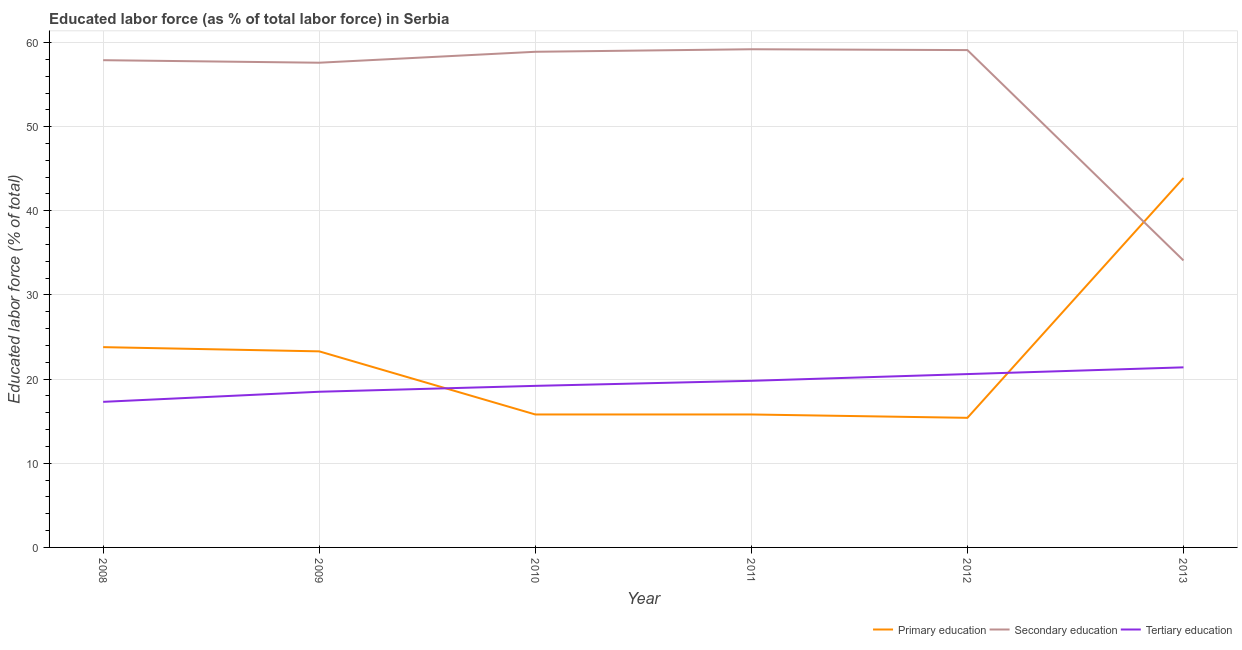How many different coloured lines are there?
Provide a succinct answer. 3. What is the percentage of labor force who received primary education in 2009?
Your response must be concise. 23.3. Across all years, what is the maximum percentage of labor force who received secondary education?
Provide a short and direct response. 59.2. Across all years, what is the minimum percentage of labor force who received primary education?
Provide a succinct answer. 15.4. In which year was the percentage of labor force who received secondary education maximum?
Ensure brevity in your answer.  2011. What is the total percentage of labor force who received tertiary education in the graph?
Offer a terse response. 116.8. What is the difference between the percentage of labor force who received secondary education in 2008 and that in 2013?
Ensure brevity in your answer.  23.8. What is the difference between the percentage of labor force who received primary education in 2010 and the percentage of labor force who received tertiary education in 2009?
Ensure brevity in your answer.  -2.7. What is the average percentage of labor force who received secondary education per year?
Your answer should be compact. 54.47. In the year 2010, what is the difference between the percentage of labor force who received primary education and percentage of labor force who received tertiary education?
Give a very brief answer. -3.4. What is the ratio of the percentage of labor force who received primary education in 2008 to that in 2010?
Give a very brief answer. 1.51. Is the difference between the percentage of labor force who received primary education in 2008 and 2010 greater than the difference between the percentage of labor force who received tertiary education in 2008 and 2010?
Give a very brief answer. Yes. What is the difference between the highest and the second highest percentage of labor force who received secondary education?
Offer a terse response. 0.1. What is the difference between the highest and the lowest percentage of labor force who received primary education?
Provide a succinct answer. 28.5. Does the percentage of labor force who received primary education monotonically increase over the years?
Your answer should be very brief. No. Is the percentage of labor force who received primary education strictly greater than the percentage of labor force who received tertiary education over the years?
Ensure brevity in your answer.  No. How many lines are there?
Your answer should be very brief. 3. Does the graph contain any zero values?
Ensure brevity in your answer.  No. How are the legend labels stacked?
Your answer should be compact. Horizontal. What is the title of the graph?
Keep it short and to the point. Educated labor force (as % of total labor force) in Serbia. Does "Labor Market" appear as one of the legend labels in the graph?
Ensure brevity in your answer.  No. What is the label or title of the Y-axis?
Provide a succinct answer. Educated labor force (% of total). What is the Educated labor force (% of total) in Primary education in 2008?
Provide a short and direct response. 23.8. What is the Educated labor force (% of total) in Secondary education in 2008?
Your response must be concise. 57.9. What is the Educated labor force (% of total) of Tertiary education in 2008?
Your answer should be compact. 17.3. What is the Educated labor force (% of total) of Primary education in 2009?
Provide a short and direct response. 23.3. What is the Educated labor force (% of total) in Secondary education in 2009?
Provide a succinct answer. 57.6. What is the Educated labor force (% of total) in Tertiary education in 2009?
Your answer should be compact. 18.5. What is the Educated labor force (% of total) of Primary education in 2010?
Ensure brevity in your answer.  15.8. What is the Educated labor force (% of total) in Secondary education in 2010?
Your answer should be compact. 58.9. What is the Educated labor force (% of total) of Tertiary education in 2010?
Make the answer very short. 19.2. What is the Educated labor force (% of total) of Primary education in 2011?
Ensure brevity in your answer.  15.8. What is the Educated labor force (% of total) in Secondary education in 2011?
Give a very brief answer. 59.2. What is the Educated labor force (% of total) of Tertiary education in 2011?
Offer a very short reply. 19.8. What is the Educated labor force (% of total) of Primary education in 2012?
Ensure brevity in your answer.  15.4. What is the Educated labor force (% of total) of Secondary education in 2012?
Make the answer very short. 59.1. What is the Educated labor force (% of total) of Tertiary education in 2012?
Your answer should be compact. 20.6. What is the Educated labor force (% of total) in Primary education in 2013?
Offer a terse response. 43.9. What is the Educated labor force (% of total) in Secondary education in 2013?
Keep it short and to the point. 34.1. What is the Educated labor force (% of total) of Tertiary education in 2013?
Ensure brevity in your answer.  21.4. Across all years, what is the maximum Educated labor force (% of total) of Primary education?
Make the answer very short. 43.9. Across all years, what is the maximum Educated labor force (% of total) in Secondary education?
Provide a short and direct response. 59.2. Across all years, what is the maximum Educated labor force (% of total) of Tertiary education?
Offer a terse response. 21.4. Across all years, what is the minimum Educated labor force (% of total) in Primary education?
Provide a succinct answer. 15.4. Across all years, what is the minimum Educated labor force (% of total) in Secondary education?
Give a very brief answer. 34.1. Across all years, what is the minimum Educated labor force (% of total) in Tertiary education?
Offer a terse response. 17.3. What is the total Educated labor force (% of total) of Primary education in the graph?
Offer a terse response. 138. What is the total Educated labor force (% of total) of Secondary education in the graph?
Make the answer very short. 326.8. What is the total Educated labor force (% of total) in Tertiary education in the graph?
Make the answer very short. 116.8. What is the difference between the Educated labor force (% of total) of Primary education in 2008 and that in 2010?
Your answer should be compact. 8. What is the difference between the Educated labor force (% of total) of Tertiary education in 2008 and that in 2010?
Your response must be concise. -1.9. What is the difference between the Educated labor force (% of total) in Primary education in 2008 and that in 2011?
Give a very brief answer. 8. What is the difference between the Educated labor force (% of total) in Tertiary education in 2008 and that in 2011?
Make the answer very short. -2.5. What is the difference between the Educated labor force (% of total) of Primary education in 2008 and that in 2012?
Your response must be concise. 8.4. What is the difference between the Educated labor force (% of total) in Secondary education in 2008 and that in 2012?
Your answer should be compact. -1.2. What is the difference between the Educated labor force (% of total) in Primary education in 2008 and that in 2013?
Provide a short and direct response. -20.1. What is the difference between the Educated labor force (% of total) in Secondary education in 2008 and that in 2013?
Your response must be concise. 23.8. What is the difference between the Educated labor force (% of total) in Secondary education in 2009 and that in 2010?
Your answer should be very brief. -1.3. What is the difference between the Educated labor force (% of total) in Tertiary education in 2009 and that in 2011?
Provide a short and direct response. -1.3. What is the difference between the Educated labor force (% of total) of Secondary education in 2009 and that in 2012?
Keep it short and to the point. -1.5. What is the difference between the Educated labor force (% of total) of Primary education in 2009 and that in 2013?
Offer a terse response. -20.6. What is the difference between the Educated labor force (% of total) in Tertiary education in 2009 and that in 2013?
Provide a short and direct response. -2.9. What is the difference between the Educated labor force (% of total) in Tertiary education in 2010 and that in 2012?
Offer a terse response. -1.4. What is the difference between the Educated labor force (% of total) of Primary education in 2010 and that in 2013?
Provide a succinct answer. -28.1. What is the difference between the Educated labor force (% of total) of Secondary education in 2010 and that in 2013?
Make the answer very short. 24.8. What is the difference between the Educated labor force (% of total) of Tertiary education in 2011 and that in 2012?
Offer a terse response. -0.8. What is the difference between the Educated labor force (% of total) of Primary education in 2011 and that in 2013?
Keep it short and to the point. -28.1. What is the difference between the Educated labor force (% of total) of Secondary education in 2011 and that in 2013?
Your response must be concise. 25.1. What is the difference between the Educated labor force (% of total) in Tertiary education in 2011 and that in 2013?
Your answer should be compact. -1.6. What is the difference between the Educated labor force (% of total) of Primary education in 2012 and that in 2013?
Your answer should be compact. -28.5. What is the difference between the Educated labor force (% of total) in Tertiary education in 2012 and that in 2013?
Provide a short and direct response. -0.8. What is the difference between the Educated labor force (% of total) in Primary education in 2008 and the Educated labor force (% of total) in Secondary education in 2009?
Make the answer very short. -33.8. What is the difference between the Educated labor force (% of total) in Primary education in 2008 and the Educated labor force (% of total) in Tertiary education in 2009?
Your response must be concise. 5.3. What is the difference between the Educated labor force (% of total) of Secondary education in 2008 and the Educated labor force (% of total) of Tertiary education in 2009?
Offer a terse response. 39.4. What is the difference between the Educated labor force (% of total) in Primary education in 2008 and the Educated labor force (% of total) in Secondary education in 2010?
Your response must be concise. -35.1. What is the difference between the Educated labor force (% of total) in Secondary education in 2008 and the Educated labor force (% of total) in Tertiary education in 2010?
Give a very brief answer. 38.7. What is the difference between the Educated labor force (% of total) of Primary education in 2008 and the Educated labor force (% of total) of Secondary education in 2011?
Provide a succinct answer. -35.4. What is the difference between the Educated labor force (% of total) of Secondary education in 2008 and the Educated labor force (% of total) of Tertiary education in 2011?
Give a very brief answer. 38.1. What is the difference between the Educated labor force (% of total) of Primary education in 2008 and the Educated labor force (% of total) of Secondary education in 2012?
Offer a very short reply. -35.3. What is the difference between the Educated labor force (% of total) in Primary education in 2008 and the Educated labor force (% of total) in Tertiary education in 2012?
Provide a short and direct response. 3.2. What is the difference between the Educated labor force (% of total) in Secondary education in 2008 and the Educated labor force (% of total) in Tertiary education in 2012?
Offer a very short reply. 37.3. What is the difference between the Educated labor force (% of total) of Primary education in 2008 and the Educated labor force (% of total) of Tertiary education in 2013?
Your answer should be compact. 2.4. What is the difference between the Educated labor force (% of total) in Secondary education in 2008 and the Educated labor force (% of total) in Tertiary education in 2013?
Provide a succinct answer. 36.5. What is the difference between the Educated labor force (% of total) in Primary education in 2009 and the Educated labor force (% of total) in Secondary education in 2010?
Offer a terse response. -35.6. What is the difference between the Educated labor force (% of total) in Primary education in 2009 and the Educated labor force (% of total) in Tertiary education in 2010?
Provide a short and direct response. 4.1. What is the difference between the Educated labor force (% of total) in Secondary education in 2009 and the Educated labor force (% of total) in Tertiary education in 2010?
Ensure brevity in your answer.  38.4. What is the difference between the Educated labor force (% of total) of Primary education in 2009 and the Educated labor force (% of total) of Secondary education in 2011?
Keep it short and to the point. -35.9. What is the difference between the Educated labor force (% of total) of Secondary education in 2009 and the Educated labor force (% of total) of Tertiary education in 2011?
Your answer should be compact. 37.8. What is the difference between the Educated labor force (% of total) of Primary education in 2009 and the Educated labor force (% of total) of Secondary education in 2012?
Keep it short and to the point. -35.8. What is the difference between the Educated labor force (% of total) in Primary education in 2009 and the Educated labor force (% of total) in Secondary education in 2013?
Your answer should be compact. -10.8. What is the difference between the Educated labor force (% of total) in Secondary education in 2009 and the Educated labor force (% of total) in Tertiary education in 2013?
Make the answer very short. 36.2. What is the difference between the Educated labor force (% of total) of Primary education in 2010 and the Educated labor force (% of total) of Secondary education in 2011?
Ensure brevity in your answer.  -43.4. What is the difference between the Educated labor force (% of total) in Secondary education in 2010 and the Educated labor force (% of total) in Tertiary education in 2011?
Your answer should be compact. 39.1. What is the difference between the Educated labor force (% of total) in Primary education in 2010 and the Educated labor force (% of total) in Secondary education in 2012?
Provide a short and direct response. -43.3. What is the difference between the Educated labor force (% of total) in Primary education in 2010 and the Educated labor force (% of total) in Tertiary education in 2012?
Provide a succinct answer. -4.8. What is the difference between the Educated labor force (% of total) of Secondary education in 2010 and the Educated labor force (% of total) of Tertiary education in 2012?
Offer a terse response. 38.3. What is the difference between the Educated labor force (% of total) of Primary education in 2010 and the Educated labor force (% of total) of Secondary education in 2013?
Provide a succinct answer. -18.3. What is the difference between the Educated labor force (% of total) in Primary education in 2010 and the Educated labor force (% of total) in Tertiary education in 2013?
Provide a short and direct response. -5.6. What is the difference between the Educated labor force (% of total) in Secondary education in 2010 and the Educated labor force (% of total) in Tertiary education in 2013?
Your response must be concise. 37.5. What is the difference between the Educated labor force (% of total) of Primary education in 2011 and the Educated labor force (% of total) of Secondary education in 2012?
Keep it short and to the point. -43.3. What is the difference between the Educated labor force (% of total) in Secondary education in 2011 and the Educated labor force (% of total) in Tertiary education in 2012?
Your answer should be very brief. 38.6. What is the difference between the Educated labor force (% of total) of Primary education in 2011 and the Educated labor force (% of total) of Secondary education in 2013?
Provide a short and direct response. -18.3. What is the difference between the Educated labor force (% of total) in Primary education in 2011 and the Educated labor force (% of total) in Tertiary education in 2013?
Provide a short and direct response. -5.6. What is the difference between the Educated labor force (% of total) in Secondary education in 2011 and the Educated labor force (% of total) in Tertiary education in 2013?
Ensure brevity in your answer.  37.8. What is the difference between the Educated labor force (% of total) of Primary education in 2012 and the Educated labor force (% of total) of Secondary education in 2013?
Make the answer very short. -18.7. What is the difference between the Educated labor force (% of total) of Primary education in 2012 and the Educated labor force (% of total) of Tertiary education in 2013?
Your answer should be very brief. -6. What is the difference between the Educated labor force (% of total) of Secondary education in 2012 and the Educated labor force (% of total) of Tertiary education in 2013?
Ensure brevity in your answer.  37.7. What is the average Educated labor force (% of total) of Primary education per year?
Make the answer very short. 23. What is the average Educated labor force (% of total) of Secondary education per year?
Provide a short and direct response. 54.47. What is the average Educated labor force (% of total) of Tertiary education per year?
Provide a succinct answer. 19.47. In the year 2008, what is the difference between the Educated labor force (% of total) in Primary education and Educated labor force (% of total) in Secondary education?
Your response must be concise. -34.1. In the year 2008, what is the difference between the Educated labor force (% of total) of Secondary education and Educated labor force (% of total) of Tertiary education?
Your answer should be very brief. 40.6. In the year 2009, what is the difference between the Educated labor force (% of total) of Primary education and Educated labor force (% of total) of Secondary education?
Offer a terse response. -34.3. In the year 2009, what is the difference between the Educated labor force (% of total) in Secondary education and Educated labor force (% of total) in Tertiary education?
Keep it short and to the point. 39.1. In the year 2010, what is the difference between the Educated labor force (% of total) in Primary education and Educated labor force (% of total) in Secondary education?
Ensure brevity in your answer.  -43.1. In the year 2010, what is the difference between the Educated labor force (% of total) in Primary education and Educated labor force (% of total) in Tertiary education?
Your response must be concise. -3.4. In the year 2010, what is the difference between the Educated labor force (% of total) of Secondary education and Educated labor force (% of total) of Tertiary education?
Make the answer very short. 39.7. In the year 2011, what is the difference between the Educated labor force (% of total) in Primary education and Educated labor force (% of total) in Secondary education?
Provide a succinct answer. -43.4. In the year 2011, what is the difference between the Educated labor force (% of total) in Secondary education and Educated labor force (% of total) in Tertiary education?
Provide a short and direct response. 39.4. In the year 2012, what is the difference between the Educated labor force (% of total) of Primary education and Educated labor force (% of total) of Secondary education?
Offer a terse response. -43.7. In the year 2012, what is the difference between the Educated labor force (% of total) of Primary education and Educated labor force (% of total) of Tertiary education?
Your answer should be very brief. -5.2. In the year 2012, what is the difference between the Educated labor force (% of total) in Secondary education and Educated labor force (% of total) in Tertiary education?
Ensure brevity in your answer.  38.5. In the year 2013, what is the difference between the Educated labor force (% of total) in Primary education and Educated labor force (% of total) in Tertiary education?
Make the answer very short. 22.5. What is the ratio of the Educated labor force (% of total) in Primary education in 2008 to that in 2009?
Make the answer very short. 1.02. What is the ratio of the Educated labor force (% of total) of Tertiary education in 2008 to that in 2009?
Your answer should be compact. 0.94. What is the ratio of the Educated labor force (% of total) in Primary education in 2008 to that in 2010?
Your response must be concise. 1.51. What is the ratio of the Educated labor force (% of total) in Tertiary education in 2008 to that in 2010?
Make the answer very short. 0.9. What is the ratio of the Educated labor force (% of total) in Primary education in 2008 to that in 2011?
Give a very brief answer. 1.51. What is the ratio of the Educated labor force (% of total) in Tertiary education in 2008 to that in 2011?
Provide a succinct answer. 0.87. What is the ratio of the Educated labor force (% of total) in Primary education in 2008 to that in 2012?
Offer a very short reply. 1.55. What is the ratio of the Educated labor force (% of total) of Secondary education in 2008 to that in 2012?
Your answer should be very brief. 0.98. What is the ratio of the Educated labor force (% of total) of Tertiary education in 2008 to that in 2012?
Offer a very short reply. 0.84. What is the ratio of the Educated labor force (% of total) in Primary education in 2008 to that in 2013?
Your answer should be very brief. 0.54. What is the ratio of the Educated labor force (% of total) of Secondary education in 2008 to that in 2013?
Offer a very short reply. 1.7. What is the ratio of the Educated labor force (% of total) in Tertiary education in 2008 to that in 2013?
Offer a very short reply. 0.81. What is the ratio of the Educated labor force (% of total) of Primary education in 2009 to that in 2010?
Make the answer very short. 1.47. What is the ratio of the Educated labor force (% of total) in Secondary education in 2009 to that in 2010?
Provide a succinct answer. 0.98. What is the ratio of the Educated labor force (% of total) in Tertiary education in 2009 to that in 2010?
Keep it short and to the point. 0.96. What is the ratio of the Educated labor force (% of total) of Primary education in 2009 to that in 2011?
Provide a short and direct response. 1.47. What is the ratio of the Educated labor force (% of total) of Secondary education in 2009 to that in 2011?
Make the answer very short. 0.97. What is the ratio of the Educated labor force (% of total) of Tertiary education in 2009 to that in 2011?
Provide a succinct answer. 0.93. What is the ratio of the Educated labor force (% of total) in Primary education in 2009 to that in 2012?
Your answer should be very brief. 1.51. What is the ratio of the Educated labor force (% of total) of Secondary education in 2009 to that in 2012?
Offer a terse response. 0.97. What is the ratio of the Educated labor force (% of total) of Tertiary education in 2009 to that in 2012?
Provide a succinct answer. 0.9. What is the ratio of the Educated labor force (% of total) of Primary education in 2009 to that in 2013?
Offer a very short reply. 0.53. What is the ratio of the Educated labor force (% of total) of Secondary education in 2009 to that in 2013?
Offer a terse response. 1.69. What is the ratio of the Educated labor force (% of total) of Tertiary education in 2009 to that in 2013?
Your answer should be very brief. 0.86. What is the ratio of the Educated labor force (% of total) of Primary education in 2010 to that in 2011?
Your answer should be very brief. 1. What is the ratio of the Educated labor force (% of total) of Tertiary education in 2010 to that in 2011?
Your answer should be very brief. 0.97. What is the ratio of the Educated labor force (% of total) in Primary education in 2010 to that in 2012?
Provide a short and direct response. 1.03. What is the ratio of the Educated labor force (% of total) in Secondary education in 2010 to that in 2012?
Provide a short and direct response. 1. What is the ratio of the Educated labor force (% of total) of Tertiary education in 2010 to that in 2012?
Offer a terse response. 0.93. What is the ratio of the Educated labor force (% of total) of Primary education in 2010 to that in 2013?
Make the answer very short. 0.36. What is the ratio of the Educated labor force (% of total) of Secondary education in 2010 to that in 2013?
Offer a very short reply. 1.73. What is the ratio of the Educated labor force (% of total) in Tertiary education in 2010 to that in 2013?
Ensure brevity in your answer.  0.9. What is the ratio of the Educated labor force (% of total) of Tertiary education in 2011 to that in 2012?
Give a very brief answer. 0.96. What is the ratio of the Educated labor force (% of total) in Primary education in 2011 to that in 2013?
Offer a very short reply. 0.36. What is the ratio of the Educated labor force (% of total) of Secondary education in 2011 to that in 2013?
Give a very brief answer. 1.74. What is the ratio of the Educated labor force (% of total) in Tertiary education in 2011 to that in 2013?
Provide a succinct answer. 0.93. What is the ratio of the Educated labor force (% of total) of Primary education in 2012 to that in 2013?
Your answer should be very brief. 0.35. What is the ratio of the Educated labor force (% of total) of Secondary education in 2012 to that in 2013?
Make the answer very short. 1.73. What is the ratio of the Educated labor force (% of total) of Tertiary education in 2012 to that in 2013?
Provide a succinct answer. 0.96. What is the difference between the highest and the second highest Educated labor force (% of total) in Primary education?
Make the answer very short. 20.1. What is the difference between the highest and the second highest Educated labor force (% of total) in Tertiary education?
Keep it short and to the point. 0.8. What is the difference between the highest and the lowest Educated labor force (% of total) of Primary education?
Provide a succinct answer. 28.5. What is the difference between the highest and the lowest Educated labor force (% of total) in Secondary education?
Provide a succinct answer. 25.1. 